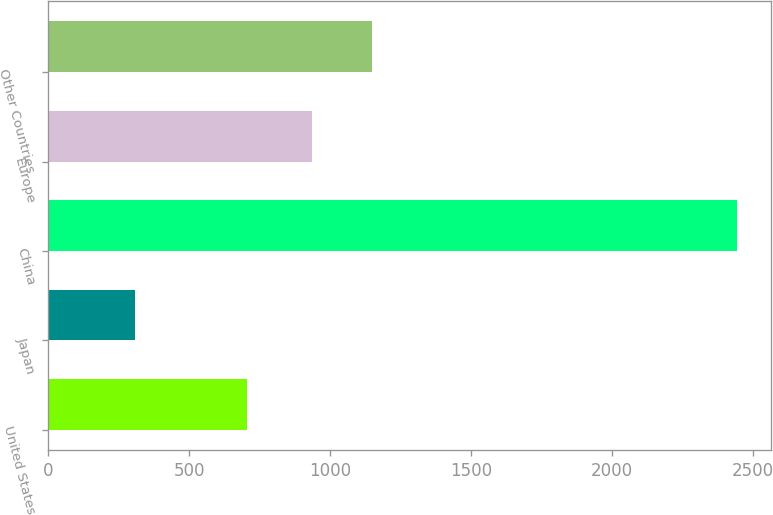<chart> <loc_0><loc_0><loc_500><loc_500><bar_chart><fcel>United States<fcel>Japan<fcel>China<fcel>Europe<fcel>Other Countries<nl><fcel>704<fcel>306<fcel>2445<fcel>934<fcel>1147.9<nl></chart> 